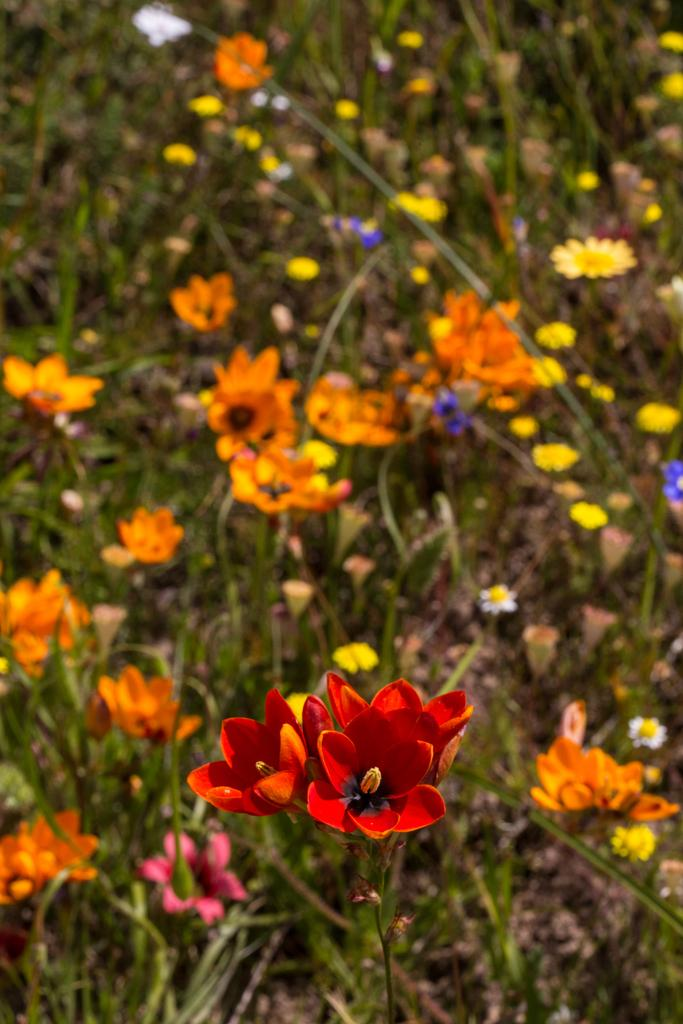What types of living organisms can be seen in the image? There are multiple plants in the image. What colors are the flowers in the image? There are flowers of various colors in the image, including red, orange, white, yellow, pink, and blue. How many oranges are hanging from the branches of the plants in the image? There are no oranges present in the image; it features plants with flowers of various colors. What is the texture of the chin of the person in the image? There is no person present in the image, only plants and flowers. 